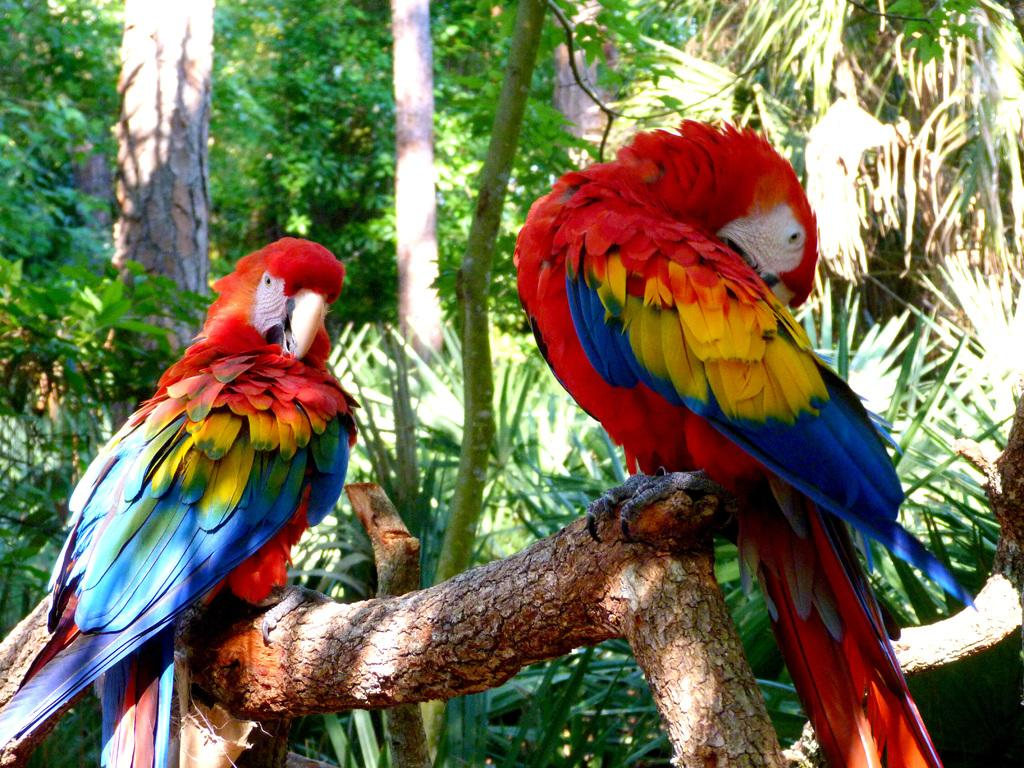What type of animals are in the image? There are parrots in the image. What colors can be seen on the parrots? The parrots are blue, yellow, and red in color. Where are the parrots located in the image? The parrots are on a tree branch. What else can be seen in the image besides the parrots? There are trees visible in the image. What type of lunch is being prepared for the parrots in the image? There is no indication in the image that the parrots are being prepared for lunch, nor is there any evidence of food preparation. 